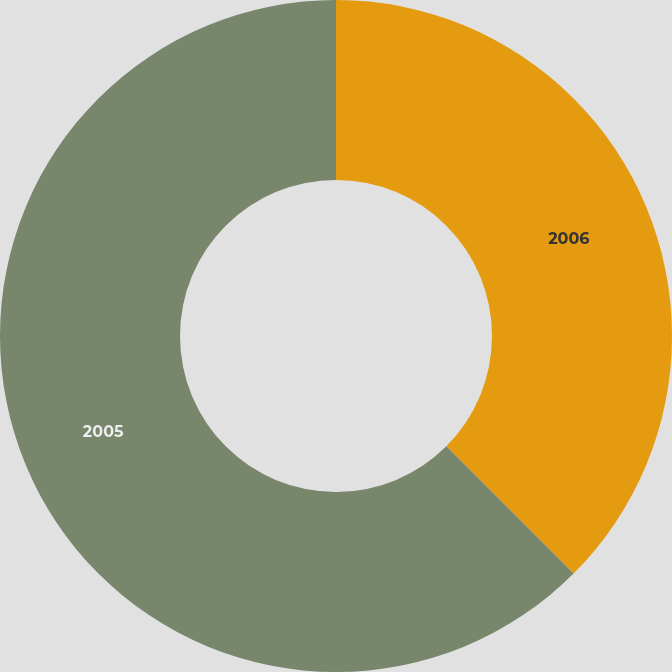Convert chart. <chart><loc_0><loc_0><loc_500><loc_500><pie_chart><fcel>2006<fcel>2005<nl><fcel>37.5%<fcel>62.5%<nl></chart> 